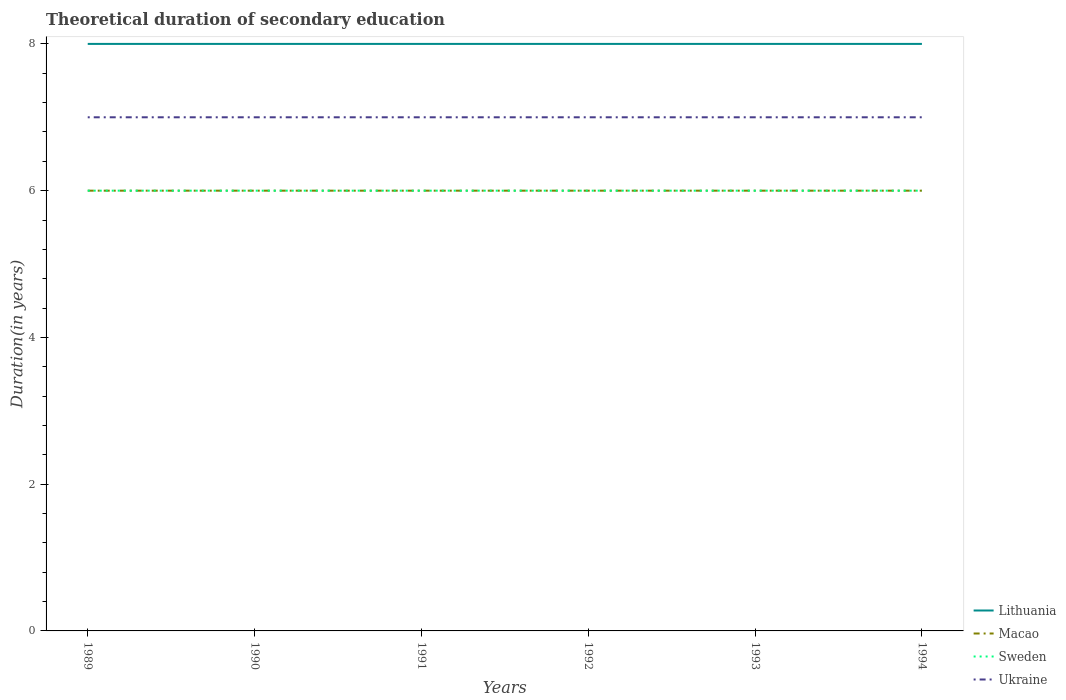How many different coloured lines are there?
Make the answer very short. 4. Is the number of lines equal to the number of legend labels?
Your answer should be compact. Yes. Across all years, what is the maximum total theoretical duration of secondary education in Sweden?
Offer a very short reply. 6. In which year was the total theoretical duration of secondary education in Sweden maximum?
Offer a very short reply. 1989. What is the total total theoretical duration of secondary education in Sweden in the graph?
Your answer should be compact. 0. What is the difference between the highest and the lowest total theoretical duration of secondary education in Macao?
Your answer should be compact. 0. Is the total theoretical duration of secondary education in Macao strictly greater than the total theoretical duration of secondary education in Sweden over the years?
Ensure brevity in your answer.  No. How many lines are there?
Your response must be concise. 4. How many years are there in the graph?
Ensure brevity in your answer.  6. What is the difference between two consecutive major ticks on the Y-axis?
Make the answer very short. 2. Does the graph contain any zero values?
Provide a succinct answer. No. Does the graph contain grids?
Provide a short and direct response. No. Where does the legend appear in the graph?
Make the answer very short. Bottom right. How are the legend labels stacked?
Offer a terse response. Vertical. What is the title of the graph?
Keep it short and to the point. Theoretical duration of secondary education. Does "Nigeria" appear as one of the legend labels in the graph?
Offer a terse response. No. What is the label or title of the Y-axis?
Your answer should be very brief. Duration(in years). What is the Duration(in years) of Lithuania in 1989?
Make the answer very short. 8. What is the Duration(in years) of Macao in 1989?
Your answer should be very brief. 6. What is the Duration(in years) in Ukraine in 1990?
Offer a terse response. 7. What is the Duration(in years) in Macao in 1991?
Offer a terse response. 6. What is the Duration(in years) in Sweden in 1992?
Your answer should be very brief. 6. What is the Duration(in years) in Ukraine in 1992?
Offer a very short reply. 7. What is the Duration(in years) in Lithuania in 1993?
Offer a terse response. 8. What is the Duration(in years) in Macao in 1993?
Offer a terse response. 6. What is the Duration(in years) in Lithuania in 1994?
Offer a terse response. 8. What is the Duration(in years) in Sweden in 1994?
Your answer should be compact. 6. Across all years, what is the maximum Duration(in years) in Sweden?
Your response must be concise. 6. What is the total Duration(in years) in Sweden in the graph?
Ensure brevity in your answer.  36. What is the total Duration(in years) in Ukraine in the graph?
Ensure brevity in your answer.  42. What is the difference between the Duration(in years) of Macao in 1989 and that in 1990?
Offer a very short reply. 0. What is the difference between the Duration(in years) in Sweden in 1989 and that in 1991?
Provide a succinct answer. 0. What is the difference between the Duration(in years) in Macao in 1989 and that in 1992?
Ensure brevity in your answer.  0. What is the difference between the Duration(in years) of Macao in 1989 and that in 1993?
Offer a very short reply. 0. What is the difference between the Duration(in years) of Sweden in 1989 and that in 1993?
Keep it short and to the point. 0. What is the difference between the Duration(in years) of Macao in 1989 and that in 1994?
Provide a short and direct response. 0. What is the difference between the Duration(in years) of Sweden in 1989 and that in 1994?
Give a very brief answer. 0. What is the difference between the Duration(in years) in Ukraine in 1989 and that in 1994?
Give a very brief answer. 0. What is the difference between the Duration(in years) of Lithuania in 1990 and that in 1991?
Your answer should be compact. 0. What is the difference between the Duration(in years) in Macao in 1990 and that in 1992?
Provide a short and direct response. 0. What is the difference between the Duration(in years) in Sweden in 1990 and that in 1992?
Offer a terse response. 0. What is the difference between the Duration(in years) in Lithuania in 1990 and that in 1993?
Your answer should be compact. 0. What is the difference between the Duration(in years) of Macao in 1990 and that in 1993?
Offer a very short reply. 0. What is the difference between the Duration(in years) of Lithuania in 1990 and that in 1994?
Your answer should be compact. 0. What is the difference between the Duration(in years) in Macao in 1990 and that in 1994?
Keep it short and to the point. 0. What is the difference between the Duration(in years) of Macao in 1991 and that in 1992?
Offer a terse response. 0. What is the difference between the Duration(in years) of Ukraine in 1991 and that in 1992?
Provide a succinct answer. 0. What is the difference between the Duration(in years) in Lithuania in 1991 and that in 1993?
Keep it short and to the point. 0. What is the difference between the Duration(in years) of Sweden in 1991 and that in 1993?
Give a very brief answer. 0. What is the difference between the Duration(in years) in Sweden in 1991 and that in 1994?
Provide a succinct answer. 0. What is the difference between the Duration(in years) of Macao in 1992 and that in 1993?
Your answer should be very brief. 0. What is the difference between the Duration(in years) of Sweden in 1992 and that in 1993?
Your answer should be very brief. 0. What is the difference between the Duration(in years) of Ukraine in 1992 and that in 1993?
Provide a short and direct response. 0. What is the difference between the Duration(in years) in Lithuania in 1992 and that in 1994?
Your answer should be very brief. 0. What is the difference between the Duration(in years) in Ukraine in 1992 and that in 1994?
Provide a succinct answer. 0. What is the difference between the Duration(in years) of Lithuania in 1993 and that in 1994?
Your answer should be very brief. 0. What is the difference between the Duration(in years) in Lithuania in 1989 and the Duration(in years) in Macao in 1990?
Provide a succinct answer. 2. What is the difference between the Duration(in years) of Lithuania in 1989 and the Duration(in years) of Ukraine in 1990?
Your answer should be very brief. 1. What is the difference between the Duration(in years) of Macao in 1989 and the Duration(in years) of Ukraine in 1990?
Give a very brief answer. -1. What is the difference between the Duration(in years) of Macao in 1989 and the Duration(in years) of Sweden in 1991?
Offer a terse response. 0. What is the difference between the Duration(in years) in Sweden in 1989 and the Duration(in years) in Ukraine in 1992?
Give a very brief answer. -1. What is the difference between the Duration(in years) of Lithuania in 1989 and the Duration(in years) of Macao in 1993?
Your response must be concise. 2. What is the difference between the Duration(in years) of Macao in 1989 and the Duration(in years) of Sweden in 1993?
Provide a succinct answer. 0. What is the difference between the Duration(in years) in Sweden in 1989 and the Duration(in years) in Ukraine in 1993?
Offer a very short reply. -1. What is the difference between the Duration(in years) in Lithuania in 1989 and the Duration(in years) in Macao in 1994?
Give a very brief answer. 2. What is the difference between the Duration(in years) in Lithuania in 1989 and the Duration(in years) in Sweden in 1994?
Provide a succinct answer. 2. What is the difference between the Duration(in years) in Lithuania in 1989 and the Duration(in years) in Ukraine in 1994?
Offer a terse response. 1. What is the difference between the Duration(in years) of Macao in 1989 and the Duration(in years) of Ukraine in 1994?
Provide a short and direct response. -1. What is the difference between the Duration(in years) of Sweden in 1989 and the Duration(in years) of Ukraine in 1994?
Ensure brevity in your answer.  -1. What is the difference between the Duration(in years) of Lithuania in 1990 and the Duration(in years) of Sweden in 1991?
Give a very brief answer. 2. What is the difference between the Duration(in years) in Lithuania in 1990 and the Duration(in years) in Ukraine in 1991?
Your answer should be compact. 1. What is the difference between the Duration(in years) of Macao in 1990 and the Duration(in years) of Ukraine in 1991?
Provide a succinct answer. -1. What is the difference between the Duration(in years) of Sweden in 1990 and the Duration(in years) of Ukraine in 1991?
Ensure brevity in your answer.  -1. What is the difference between the Duration(in years) in Lithuania in 1990 and the Duration(in years) in Macao in 1992?
Make the answer very short. 2. What is the difference between the Duration(in years) of Macao in 1990 and the Duration(in years) of Ukraine in 1992?
Make the answer very short. -1. What is the difference between the Duration(in years) in Sweden in 1990 and the Duration(in years) in Ukraine in 1992?
Your answer should be very brief. -1. What is the difference between the Duration(in years) in Lithuania in 1990 and the Duration(in years) in Macao in 1993?
Ensure brevity in your answer.  2. What is the difference between the Duration(in years) in Lithuania in 1990 and the Duration(in years) in Sweden in 1993?
Provide a short and direct response. 2. What is the difference between the Duration(in years) in Lithuania in 1990 and the Duration(in years) in Ukraine in 1993?
Your answer should be compact. 1. What is the difference between the Duration(in years) of Sweden in 1990 and the Duration(in years) of Ukraine in 1993?
Provide a succinct answer. -1. What is the difference between the Duration(in years) of Lithuania in 1990 and the Duration(in years) of Macao in 1994?
Make the answer very short. 2. What is the difference between the Duration(in years) in Macao in 1990 and the Duration(in years) in Ukraine in 1994?
Give a very brief answer. -1. What is the difference between the Duration(in years) in Lithuania in 1991 and the Duration(in years) in Macao in 1992?
Keep it short and to the point. 2. What is the difference between the Duration(in years) in Sweden in 1991 and the Duration(in years) in Ukraine in 1992?
Your answer should be very brief. -1. What is the difference between the Duration(in years) of Lithuania in 1991 and the Duration(in years) of Macao in 1993?
Keep it short and to the point. 2. What is the difference between the Duration(in years) of Lithuania in 1991 and the Duration(in years) of Macao in 1994?
Provide a succinct answer. 2. What is the difference between the Duration(in years) of Lithuania in 1991 and the Duration(in years) of Sweden in 1994?
Offer a terse response. 2. What is the difference between the Duration(in years) of Macao in 1991 and the Duration(in years) of Ukraine in 1994?
Your answer should be very brief. -1. What is the difference between the Duration(in years) of Sweden in 1991 and the Duration(in years) of Ukraine in 1994?
Your answer should be compact. -1. What is the difference between the Duration(in years) in Lithuania in 1992 and the Duration(in years) in Macao in 1993?
Ensure brevity in your answer.  2. What is the difference between the Duration(in years) in Lithuania in 1992 and the Duration(in years) in Ukraine in 1993?
Give a very brief answer. 1. What is the difference between the Duration(in years) in Macao in 1992 and the Duration(in years) in Sweden in 1993?
Your answer should be very brief. 0. What is the difference between the Duration(in years) in Lithuania in 1992 and the Duration(in years) in Sweden in 1994?
Offer a very short reply. 2. What is the difference between the Duration(in years) in Macao in 1992 and the Duration(in years) in Ukraine in 1994?
Give a very brief answer. -1. What is the difference between the Duration(in years) in Macao in 1993 and the Duration(in years) in Sweden in 1994?
Offer a terse response. 0. What is the difference between the Duration(in years) in Macao in 1993 and the Duration(in years) in Ukraine in 1994?
Provide a succinct answer. -1. What is the difference between the Duration(in years) in Sweden in 1993 and the Duration(in years) in Ukraine in 1994?
Provide a succinct answer. -1. What is the average Duration(in years) of Sweden per year?
Provide a short and direct response. 6. In the year 1989, what is the difference between the Duration(in years) of Lithuania and Duration(in years) of Ukraine?
Make the answer very short. 1. In the year 1989, what is the difference between the Duration(in years) of Macao and Duration(in years) of Sweden?
Offer a very short reply. 0. In the year 1990, what is the difference between the Duration(in years) in Lithuania and Duration(in years) in Ukraine?
Provide a succinct answer. 1. In the year 1990, what is the difference between the Duration(in years) in Macao and Duration(in years) in Sweden?
Your answer should be compact. 0. In the year 1990, what is the difference between the Duration(in years) of Macao and Duration(in years) of Ukraine?
Ensure brevity in your answer.  -1. In the year 1991, what is the difference between the Duration(in years) of Lithuania and Duration(in years) of Sweden?
Ensure brevity in your answer.  2. In the year 1991, what is the difference between the Duration(in years) of Lithuania and Duration(in years) of Ukraine?
Keep it short and to the point. 1. In the year 1991, what is the difference between the Duration(in years) of Macao and Duration(in years) of Sweden?
Your response must be concise. 0. In the year 1992, what is the difference between the Duration(in years) in Macao and Duration(in years) in Ukraine?
Ensure brevity in your answer.  -1. In the year 1992, what is the difference between the Duration(in years) of Sweden and Duration(in years) of Ukraine?
Your answer should be compact. -1. In the year 1993, what is the difference between the Duration(in years) of Macao and Duration(in years) of Ukraine?
Your answer should be compact. -1. In the year 1994, what is the difference between the Duration(in years) of Lithuania and Duration(in years) of Ukraine?
Give a very brief answer. 1. In the year 1994, what is the difference between the Duration(in years) of Macao and Duration(in years) of Sweden?
Your answer should be compact. 0. In the year 1994, what is the difference between the Duration(in years) of Sweden and Duration(in years) of Ukraine?
Your answer should be very brief. -1. What is the ratio of the Duration(in years) of Lithuania in 1989 to that in 1990?
Make the answer very short. 1. What is the ratio of the Duration(in years) in Macao in 1989 to that in 1990?
Offer a terse response. 1. What is the ratio of the Duration(in years) of Sweden in 1989 to that in 1990?
Give a very brief answer. 1. What is the ratio of the Duration(in years) in Lithuania in 1989 to that in 1991?
Offer a very short reply. 1. What is the ratio of the Duration(in years) of Sweden in 1989 to that in 1991?
Provide a succinct answer. 1. What is the ratio of the Duration(in years) of Ukraine in 1989 to that in 1991?
Make the answer very short. 1. What is the ratio of the Duration(in years) in Sweden in 1989 to that in 1992?
Give a very brief answer. 1. What is the ratio of the Duration(in years) of Ukraine in 1989 to that in 1992?
Ensure brevity in your answer.  1. What is the ratio of the Duration(in years) of Macao in 1989 to that in 1993?
Your answer should be very brief. 1. What is the ratio of the Duration(in years) of Sweden in 1989 to that in 1993?
Offer a very short reply. 1. What is the ratio of the Duration(in years) of Ukraine in 1989 to that in 1993?
Keep it short and to the point. 1. What is the ratio of the Duration(in years) of Lithuania in 1989 to that in 1994?
Your response must be concise. 1. What is the ratio of the Duration(in years) of Lithuania in 1990 to that in 1991?
Ensure brevity in your answer.  1. What is the ratio of the Duration(in years) in Macao in 1990 to that in 1991?
Your answer should be very brief. 1. What is the ratio of the Duration(in years) of Lithuania in 1990 to that in 1992?
Your answer should be compact. 1. What is the ratio of the Duration(in years) of Macao in 1990 to that in 1992?
Make the answer very short. 1. What is the ratio of the Duration(in years) in Sweden in 1990 to that in 1992?
Give a very brief answer. 1. What is the ratio of the Duration(in years) of Lithuania in 1990 to that in 1993?
Offer a very short reply. 1. What is the ratio of the Duration(in years) in Macao in 1990 to that in 1993?
Keep it short and to the point. 1. What is the ratio of the Duration(in years) of Macao in 1990 to that in 1994?
Offer a very short reply. 1. What is the ratio of the Duration(in years) in Macao in 1991 to that in 1992?
Ensure brevity in your answer.  1. What is the ratio of the Duration(in years) of Sweden in 1991 to that in 1992?
Your answer should be very brief. 1. What is the ratio of the Duration(in years) in Ukraine in 1991 to that in 1993?
Keep it short and to the point. 1. What is the ratio of the Duration(in years) of Lithuania in 1991 to that in 1994?
Your response must be concise. 1. What is the ratio of the Duration(in years) of Macao in 1991 to that in 1994?
Give a very brief answer. 1. What is the ratio of the Duration(in years) of Lithuania in 1992 to that in 1993?
Ensure brevity in your answer.  1. What is the ratio of the Duration(in years) in Sweden in 1992 to that in 1994?
Offer a very short reply. 1. What is the ratio of the Duration(in years) in Lithuania in 1993 to that in 1994?
Your answer should be compact. 1. What is the ratio of the Duration(in years) of Macao in 1993 to that in 1994?
Offer a terse response. 1. What is the ratio of the Duration(in years) in Sweden in 1993 to that in 1994?
Give a very brief answer. 1. What is the difference between the highest and the lowest Duration(in years) of Sweden?
Offer a very short reply. 0. 